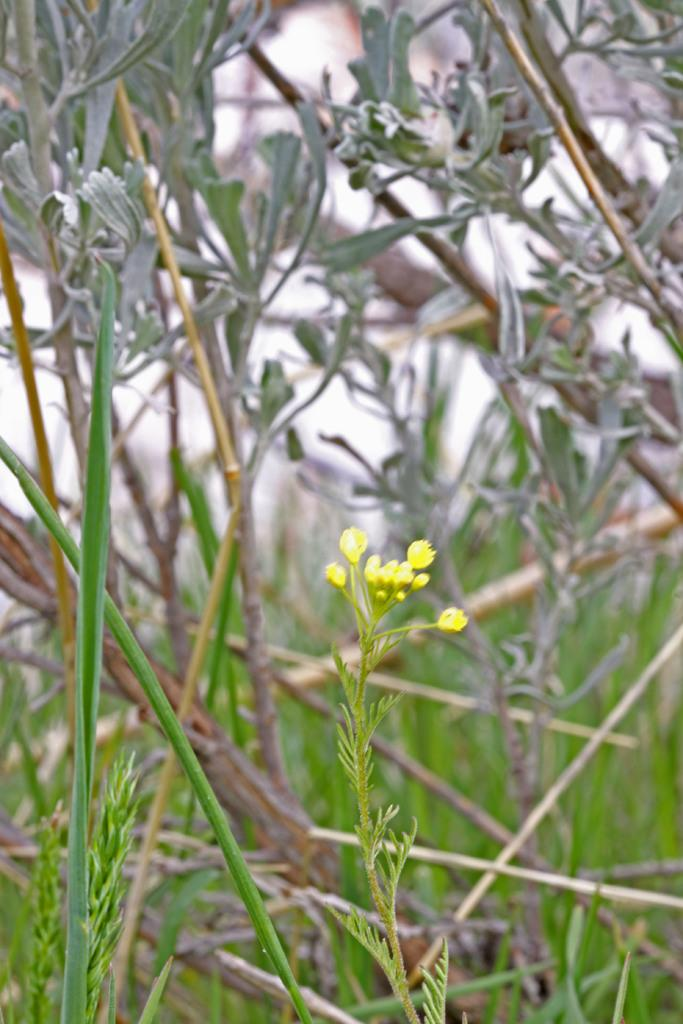What type of living organisms can be seen in the image? The image contains plants. What specific part of the plants is the focus of the image? There are flowers in the center of the image. How would you describe the appearance of the background in the image? The background of the image is blurred. What type of vegetation is visible in the background? There is grass in the background of the image. What type of joke is the brother telling in the image? There is no brother or joke present in the image; it features plants with flowers and a blurred background. 